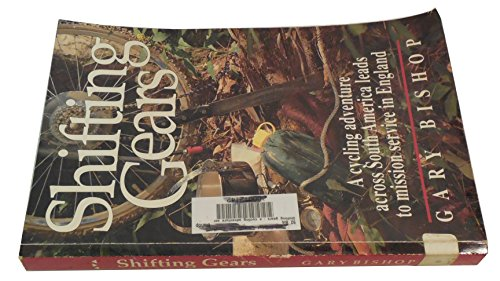What could be the significance of using a bicycle in the context of this book? The bicycle signifies more than transportation; it embodies the journey, adventure, and the physical and mental challenges associated with long-distance cycling. In this context, it represents not only a journey through South America but also a metaphorical journey of self-discovery and mission. 